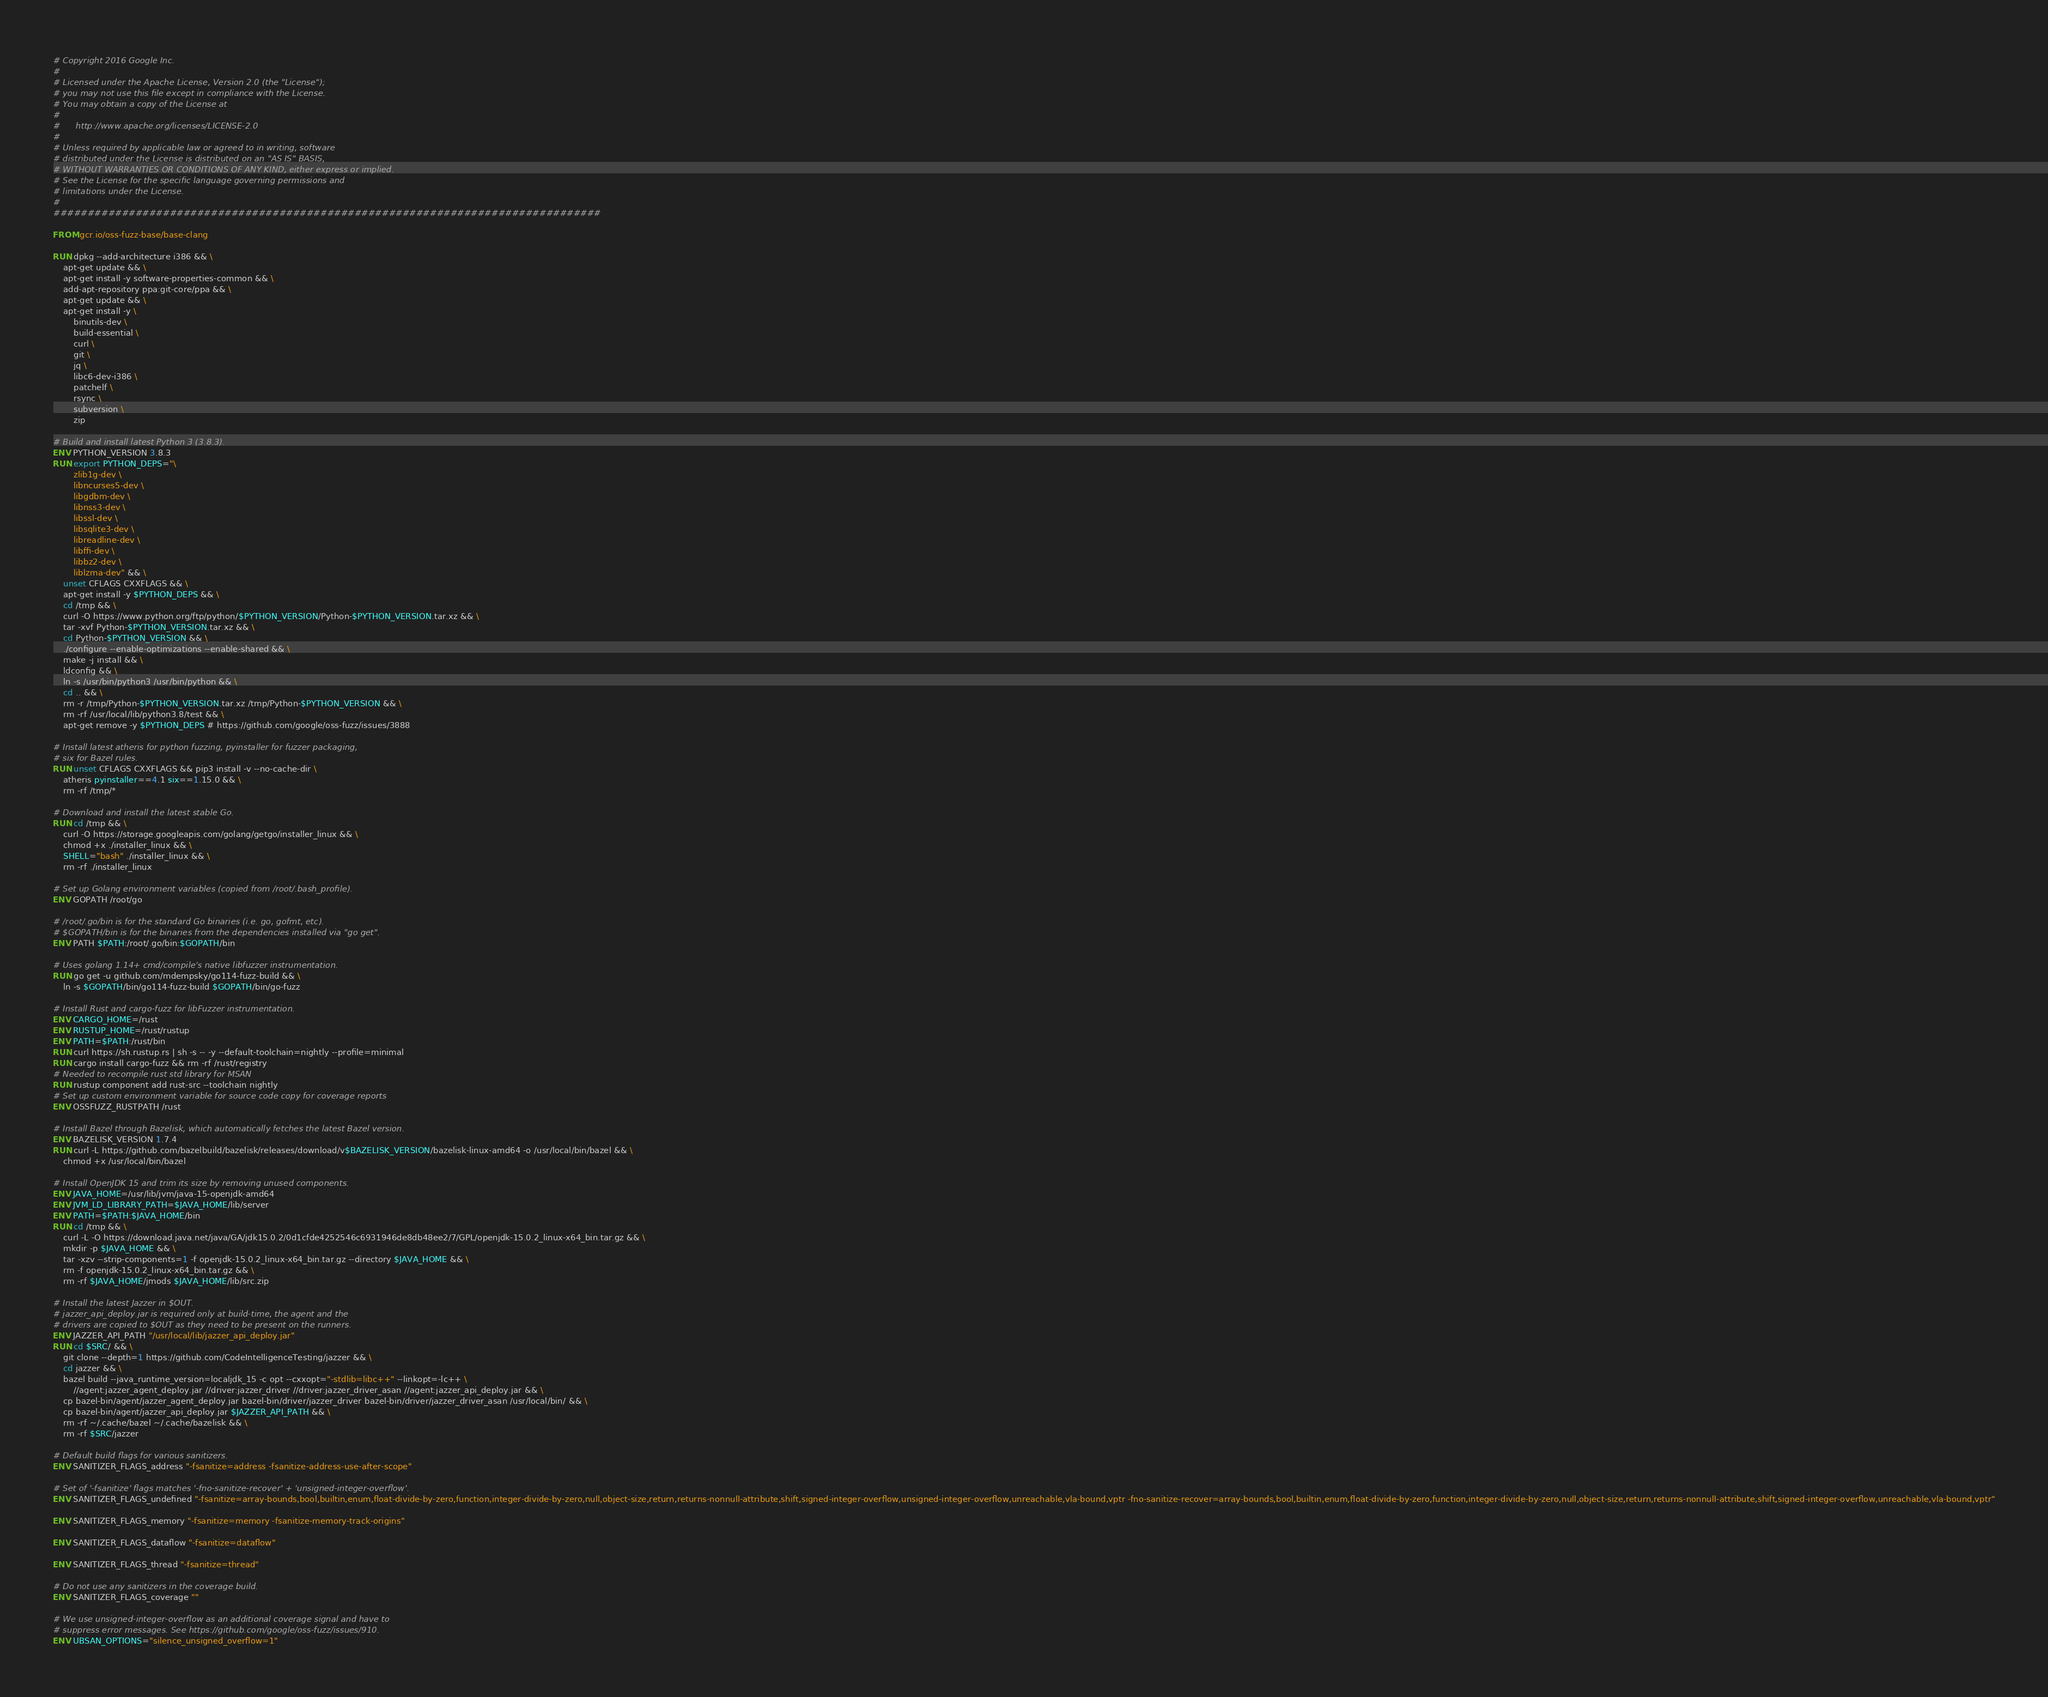<code> <loc_0><loc_0><loc_500><loc_500><_Dockerfile_># Copyright 2016 Google Inc.
#
# Licensed under the Apache License, Version 2.0 (the "License");
# you may not use this file except in compliance with the License.
# You may obtain a copy of the License at
#
#      http://www.apache.org/licenses/LICENSE-2.0
#
# Unless required by applicable law or agreed to in writing, software
# distributed under the License is distributed on an "AS IS" BASIS,
# WITHOUT WARRANTIES OR CONDITIONS OF ANY KIND, either express or implied.
# See the License for the specific language governing permissions and
# limitations under the License.
#
################################################################################

FROM gcr.io/oss-fuzz-base/base-clang

RUN dpkg --add-architecture i386 && \
    apt-get update && \
    apt-get install -y software-properties-common && \
    add-apt-repository ppa:git-core/ppa && \
    apt-get update && \
    apt-get install -y \
        binutils-dev \
        build-essential \
        curl \
        git \
        jq \
        libc6-dev-i386 \
        patchelf \
        rsync \
        subversion \
        zip

# Build and install latest Python 3 (3.8.3).
ENV PYTHON_VERSION 3.8.3
RUN export PYTHON_DEPS="\
        zlib1g-dev \
        libncurses5-dev \
        libgdbm-dev \
        libnss3-dev \
        libssl-dev \
        libsqlite3-dev \
        libreadline-dev \
        libffi-dev \
        libbz2-dev \
        liblzma-dev" && \
    unset CFLAGS CXXFLAGS && \
    apt-get install -y $PYTHON_DEPS && \
    cd /tmp && \
    curl -O https://www.python.org/ftp/python/$PYTHON_VERSION/Python-$PYTHON_VERSION.tar.xz && \
    tar -xvf Python-$PYTHON_VERSION.tar.xz && \
    cd Python-$PYTHON_VERSION && \
    ./configure --enable-optimizations --enable-shared && \
    make -j install && \
    ldconfig && \
    ln -s /usr/bin/python3 /usr/bin/python && \
    cd .. && \
    rm -r /tmp/Python-$PYTHON_VERSION.tar.xz /tmp/Python-$PYTHON_VERSION && \
    rm -rf /usr/local/lib/python3.8/test && \
    apt-get remove -y $PYTHON_DEPS # https://github.com/google/oss-fuzz/issues/3888

# Install latest atheris for python fuzzing, pyinstaller for fuzzer packaging,
# six for Bazel rules.
RUN unset CFLAGS CXXFLAGS && pip3 install -v --no-cache-dir \
    atheris pyinstaller==4.1 six==1.15.0 && \
    rm -rf /tmp/*

# Download and install the latest stable Go.
RUN cd /tmp && \
    curl -O https://storage.googleapis.com/golang/getgo/installer_linux && \
    chmod +x ./installer_linux && \
    SHELL="bash" ./installer_linux && \
    rm -rf ./installer_linux

# Set up Golang environment variables (copied from /root/.bash_profile).
ENV GOPATH /root/go

# /root/.go/bin is for the standard Go binaries (i.e. go, gofmt, etc).
# $GOPATH/bin is for the binaries from the dependencies installed via "go get".
ENV PATH $PATH:/root/.go/bin:$GOPATH/bin

# Uses golang 1.14+ cmd/compile's native libfuzzer instrumentation.
RUN go get -u github.com/mdempsky/go114-fuzz-build && \
    ln -s $GOPATH/bin/go114-fuzz-build $GOPATH/bin/go-fuzz

# Install Rust and cargo-fuzz for libFuzzer instrumentation.
ENV CARGO_HOME=/rust
ENV RUSTUP_HOME=/rust/rustup
ENV PATH=$PATH:/rust/bin
RUN curl https://sh.rustup.rs | sh -s -- -y --default-toolchain=nightly --profile=minimal
RUN cargo install cargo-fuzz && rm -rf /rust/registry
# Needed to recompile rust std library for MSAN
RUN rustup component add rust-src --toolchain nightly
# Set up custom environment variable for source code copy for coverage reports
ENV OSSFUZZ_RUSTPATH /rust

# Install Bazel through Bazelisk, which automatically fetches the latest Bazel version.
ENV BAZELISK_VERSION 1.7.4
RUN curl -L https://github.com/bazelbuild/bazelisk/releases/download/v$BAZELISK_VERSION/bazelisk-linux-amd64 -o /usr/local/bin/bazel && \
    chmod +x /usr/local/bin/bazel

# Install OpenJDK 15 and trim its size by removing unused components.
ENV JAVA_HOME=/usr/lib/jvm/java-15-openjdk-amd64
ENV JVM_LD_LIBRARY_PATH=$JAVA_HOME/lib/server
ENV PATH=$PATH:$JAVA_HOME/bin
RUN cd /tmp && \
    curl -L -O https://download.java.net/java/GA/jdk15.0.2/0d1cfde4252546c6931946de8db48ee2/7/GPL/openjdk-15.0.2_linux-x64_bin.tar.gz && \
    mkdir -p $JAVA_HOME && \
    tar -xzv --strip-components=1 -f openjdk-15.0.2_linux-x64_bin.tar.gz --directory $JAVA_HOME && \
    rm -f openjdk-15.0.2_linux-x64_bin.tar.gz && \
    rm -rf $JAVA_HOME/jmods $JAVA_HOME/lib/src.zip

# Install the latest Jazzer in $OUT.
# jazzer_api_deploy.jar is required only at build-time, the agent and the
# drivers are copied to $OUT as they need to be present on the runners.
ENV JAZZER_API_PATH "/usr/local/lib/jazzer_api_deploy.jar"
RUN cd $SRC/ && \
    git clone --depth=1 https://github.com/CodeIntelligenceTesting/jazzer && \
    cd jazzer && \
    bazel build --java_runtime_version=localjdk_15 -c opt --cxxopt="-stdlib=libc++" --linkopt=-lc++ \
        //agent:jazzer_agent_deploy.jar //driver:jazzer_driver //driver:jazzer_driver_asan //agent:jazzer_api_deploy.jar && \
    cp bazel-bin/agent/jazzer_agent_deploy.jar bazel-bin/driver/jazzer_driver bazel-bin/driver/jazzer_driver_asan /usr/local/bin/ && \
    cp bazel-bin/agent/jazzer_api_deploy.jar $JAZZER_API_PATH && \
    rm -rf ~/.cache/bazel ~/.cache/bazelisk && \
    rm -rf $SRC/jazzer

# Default build flags for various sanitizers.
ENV SANITIZER_FLAGS_address "-fsanitize=address -fsanitize-address-use-after-scope"

# Set of '-fsanitize' flags matches '-fno-sanitize-recover' + 'unsigned-integer-overflow'.
ENV SANITIZER_FLAGS_undefined "-fsanitize=array-bounds,bool,builtin,enum,float-divide-by-zero,function,integer-divide-by-zero,null,object-size,return,returns-nonnull-attribute,shift,signed-integer-overflow,unsigned-integer-overflow,unreachable,vla-bound,vptr -fno-sanitize-recover=array-bounds,bool,builtin,enum,float-divide-by-zero,function,integer-divide-by-zero,null,object-size,return,returns-nonnull-attribute,shift,signed-integer-overflow,unreachable,vla-bound,vptr"

ENV SANITIZER_FLAGS_memory "-fsanitize=memory -fsanitize-memory-track-origins"

ENV SANITIZER_FLAGS_dataflow "-fsanitize=dataflow"

ENV SANITIZER_FLAGS_thread "-fsanitize=thread"

# Do not use any sanitizers in the coverage build.
ENV SANITIZER_FLAGS_coverage ""

# We use unsigned-integer-overflow as an additional coverage signal and have to
# suppress error messages. See https://github.com/google/oss-fuzz/issues/910.
ENV UBSAN_OPTIONS="silence_unsigned_overflow=1"
</code> 